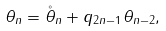<formula> <loc_0><loc_0><loc_500><loc_500>\theta _ { n } = \mathring { \theta } _ { n } + q _ { 2 n - 1 } \theta _ { n - 2 } ,</formula> 